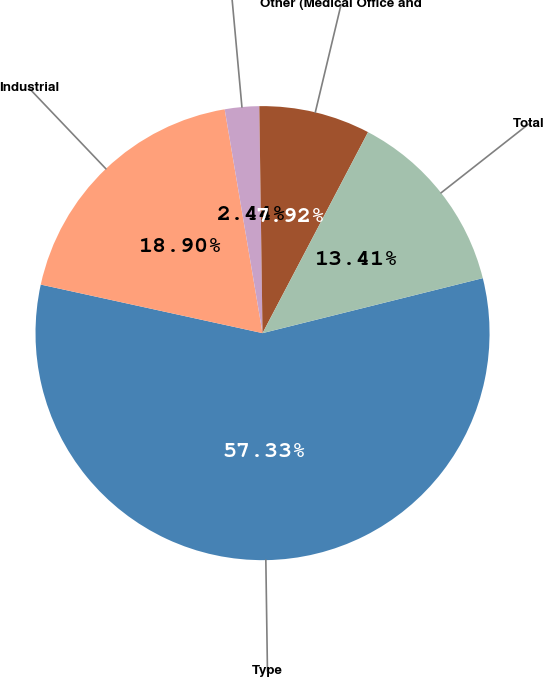Convert chart. <chart><loc_0><loc_0><loc_500><loc_500><pie_chart><fcel>Type<fcel>Industrial<fcel>Office<fcel>Other (Medical Office and<fcel>Total<nl><fcel>57.32%<fcel>18.9%<fcel>2.44%<fcel>7.92%<fcel>13.41%<nl></chart> 